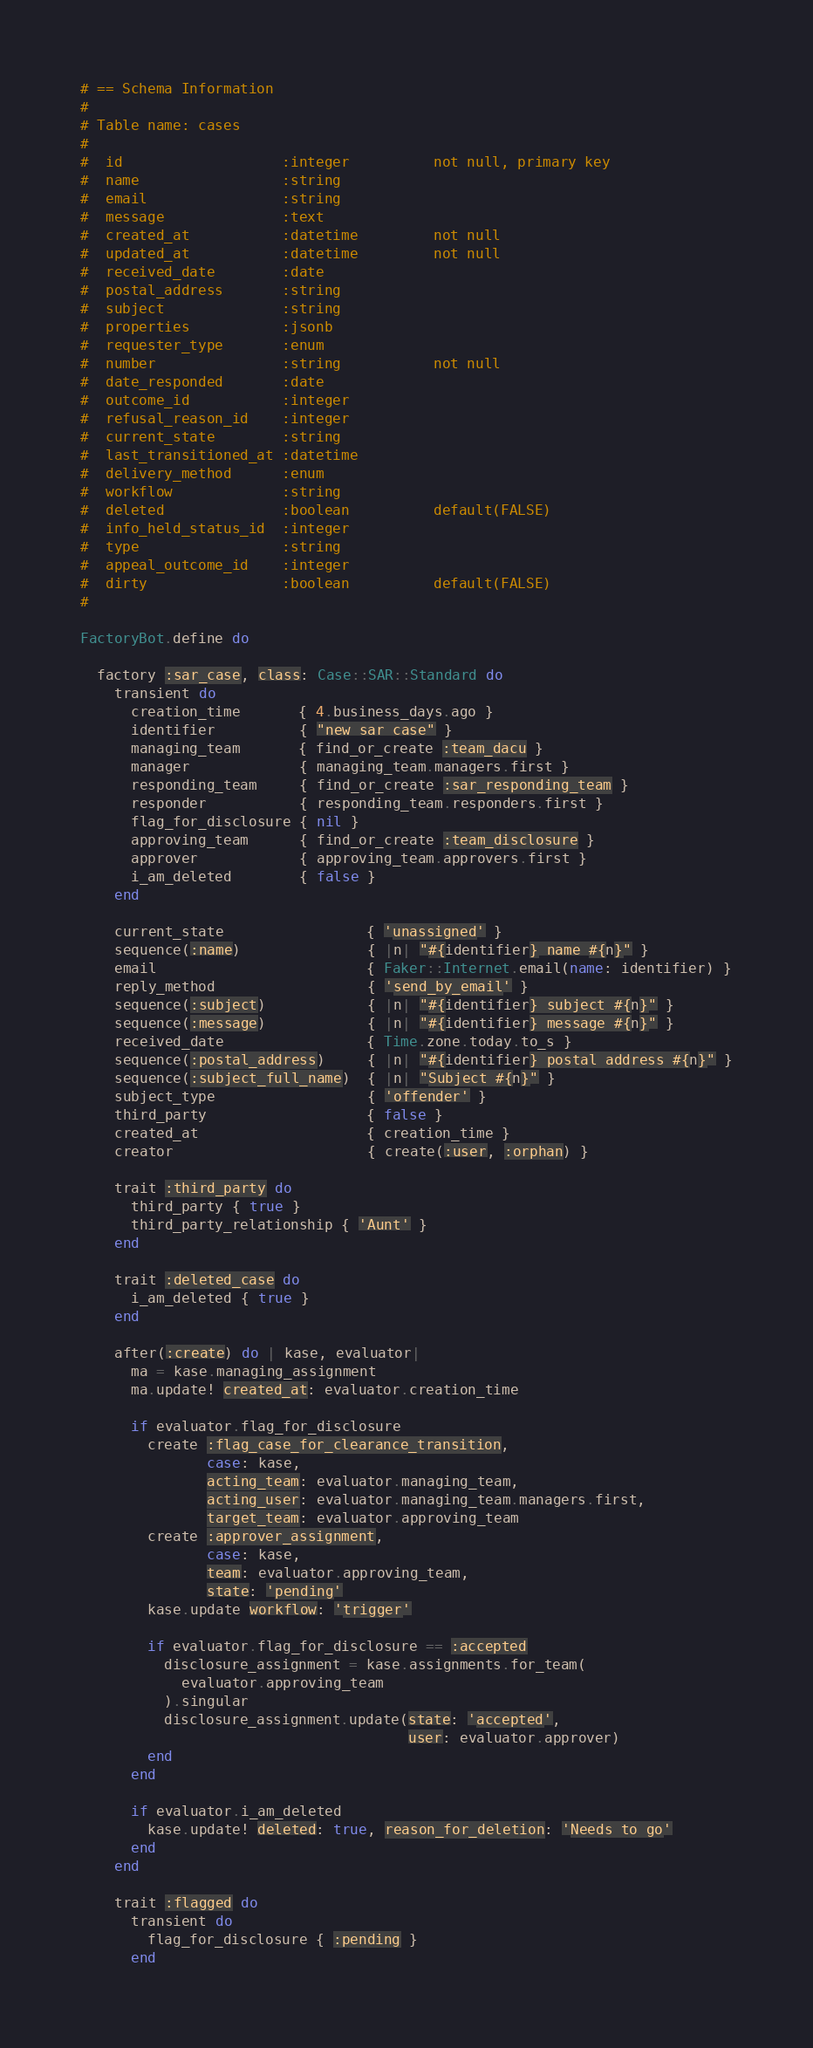Convert code to text. <code><loc_0><loc_0><loc_500><loc_500><_Ruby_># == Schema Information
#
# Table name: cases
#
#  id                   :integer          not null, primary key
#  name                 :string
#  email                :string
#  message              :text
#  created_at           :datetime         not null
#  updated_at           :datetime         not null
#  received_date        :date
#  postal_address       :string
#  subject              :string
#  properties           :jsonb
#  requester_type       :enum
#  number               :string           not null
#  date_responded       :date
#  outcome_id           :integer
#  refusal_reason_id    :integer
#  current_state        :string
#  last_transitioned_at :datetime
#  delivery_method      :enum
#  workflow             :string
#  deleted              :boolean          default(FALSE)
#  info_held_status_id  :integer
#  type                 :string
#  appeal_outcome_id    :integer
#  dirty                :boolean          default(FALSE)
#

FactoryBot.define do

  factory :sar_case, class: Case::SAR::Standard do
    transient do
      creation_time       { 4.business_days.ago }
      identifier          { "new sar case" }
      managing_team       { find_or_create :team_dacu }
      manager             { managing_team.managers.first }
      responding_team     { find_or_create :sar_responding_team }
      responder           { responding_team.responders.first }
      flag_for_disclosure { nil }
      approving_team      { find_or_create :team_disclosure }
      approver            { approving_team.approvers.first }
      i_am_deleted        { false }
    end

    current_state                 { 'unassigned' }
    sequence(:name)               { |n| "#{identifier} name #{n}" }
    email                         { Faker::Internet.email(name: identifier) }
    reply_method                  { 'send_by_email' }
    sequence(:subject)            { |n| "#{identifier} subject #{n}" }
    sequence(:message)            { |n| "#{identifier} message #{n}" }
    received_date                 { Time.zone.today.to_s }
    sequence(:postal_address)     { |n| "#{identifier} postal address #{n}" }
    sequence(:subject_full_name)  { |n| "Subject #{n}" }
    subject_type                  { 'offender' }
    third_party                   { false }
    created_at                    { creation_time }
    creator                       { create(:user, :orphan) }

    trait :third_party do
      third_party { true }
      third_party_relationship { 'Aunt' }
    end

    trait :deleted_case do
      i_am_deleted { true }
    end

    after(:create) do | kase, evaluator|
      ma = kase.managing_assignment
      ma.update! created_at: evaluator.creation_time

      if evaluator.flag_for_disclosure
        create :flag_case_for_clearance_transition,
               case: kase,
               acting_team: evaluator.managing_team,
               acting_user: evaluator.managing_team.managers.first,
               target_team: evaluator.approving_team
        create :approver_assignment,
               case: kase,
               team: evaluator.approving_team,
               state: 'pending'
        kase.update workflow: 'trigger'

        if evaluator.flag_for_disclosure == :accepted
          disclosure_assignment = kase.assignments.for_team(
            evaluator.approving_team
          ).singular
          disclosure_assignment.update(state: 'accepted',
                                       user: evaluator.approver)
        end
      end

      if evaluator.i_am_deleted
        kase.update! deleted: true, reason_for_deletion: 'Needs to go'
      end
    end

    trait :flagged do
      transient do
        flag_for_disclosure { :pending }
      end</code> 